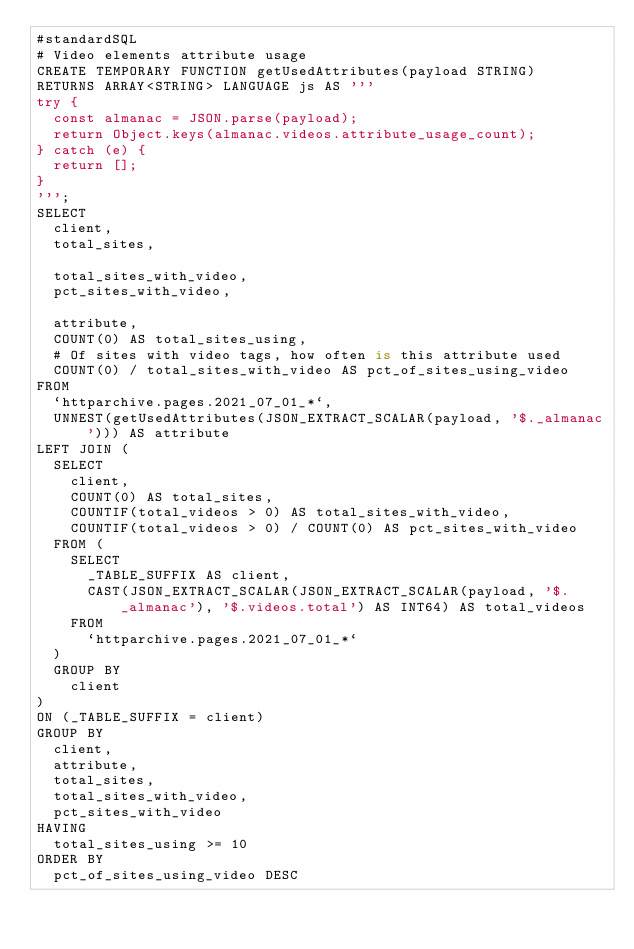Convert code to text. <code><loc_0><loc_0><loc_500><loc_500><_SQL_>#standardSQL
# Video elements attribute usage
CREATE TEMPORARY FUNCTION getUsedAttributes(payload STRING)
RETURNS ARRAY<STRING> LANGUAGE js AS '''
try {
  const almanac = JSON.parse(payload);
  return Object.keys(almanac.videos.attribute_usage_count);
} catch (e) {
  return [];
}
''';
SELECT
  client,
  total_sites,

  total_sites_with_video,
  pct_sites_with_video,

  attribute,
  COUNT(0) AS total_sites_using,
  # Of sites with video tags, how often is this attribute used
  COUNT(0) / total_sites_with_video AS pct_of_sites_using_video
FROM
  `httparchive.pages.2021_07_01_*`,
  UNNEST(getUsedAttributes(JSON_EXTRACT_SCALAR(payload, '$._almanac'))) AS attribute
LEFT JOIN (
  SELECT
    client,
    COUNT(0) AS total_sites,
    COUNTIF(total_videos > 0) AS total_sites_with_video,
    COUNTIF(total_videos > 0) / COUNT(0) AS pct_sites_with_video
  FROM (
    SELECT
      _TABLE_SUFFIX AS client,
      CAST(JSON_EXTRACT_SCALAR(JSON_EXTRACT_SCALAR(payload, '$._almanac'), '$.videos.total') AS INT64) AS total_videos
    FROM
      `httparchive.pages.2021_07_01_*`
  )
  GROUP BY
    client
)
ON (_TABLE_SUFFIX = client)
GROUP BY
  client,
  attribute,
  total_sites,
  total_sites_with_video,
  pct_sites_with_video
HAVING
  total_sites_using >= 10
ORDER BY
  pct_of_sites_using_video DESC
</code> 